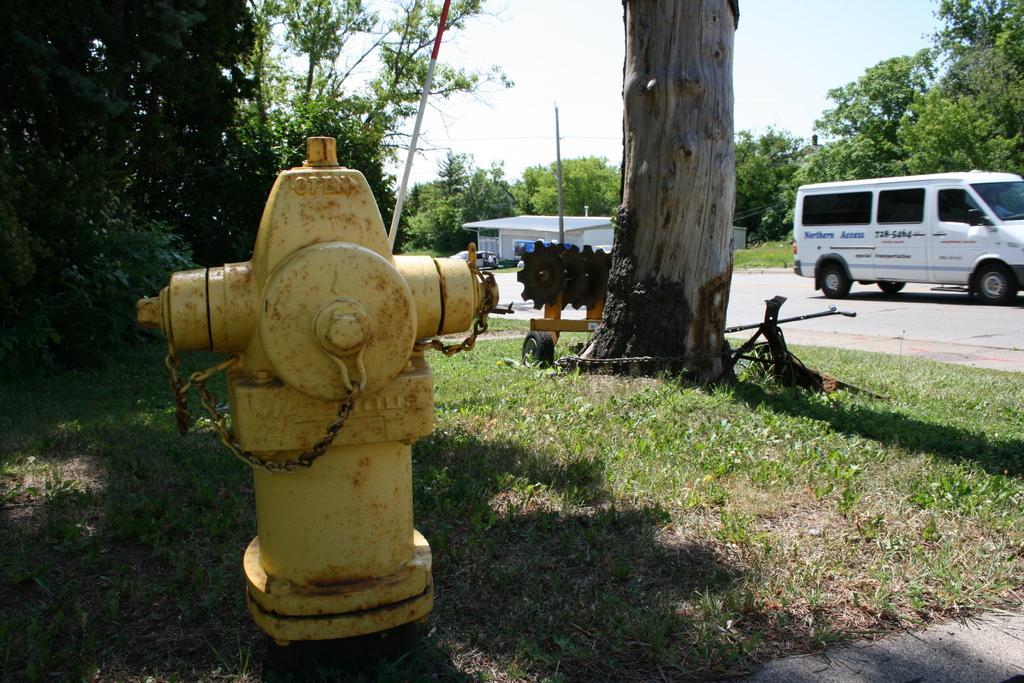How would you summarize this image in a sentence or two? In the image there is a fire extinguisher, around that there is some grass and trees. Beside the trees there is a road and on the road there is a vehicle. Behind the vehicle there are a lot of trees. 